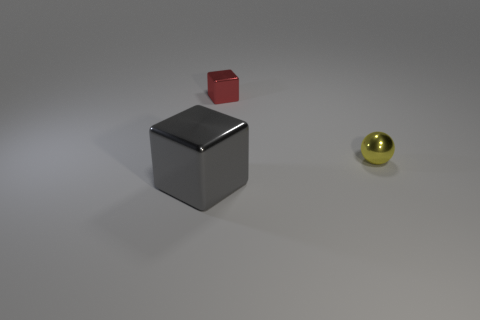Add 2 brown things. How many objects exist? 5 Subtract all cubes. How many objects are left? 1 Add 3 large gray cylinders. How many large gray cylinders exist? 3 Subtract 1 gray blocks. How many objects are left? 2 Subtract all tiny blue matte balls. Subtract all shiny objects. How many objects are left? 0 Add 3 metallic balls. How many metallic balls are left? 4 